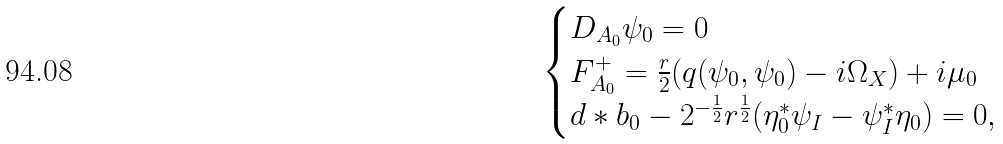Convert formula to latex. <formula><loc_0><loc_0><loc_500><loc_500>\begin{cases} D _ { A _ { 0 } } \psi _ { 0 } = 0 \\ F _ { A _ { 0 } } ^ { + } = \frac { r } { 2 } ( q ( \psi _ { 0 } , \psi _ { 0 } ) - i \Omega _ { X } ) + i \mu _ { 0 } \\ d * b _ { 0 } - 2 ^ { - \frac { 1 } { 2 } } r ^ { \frac { 1 } { 2 } } ( \eta _ { 0 } ^ { * } \psi _ { I } - \psi _ { I } ^ { * } \eta _ { 0 } ) = 0 , \end{cases}</formula> 